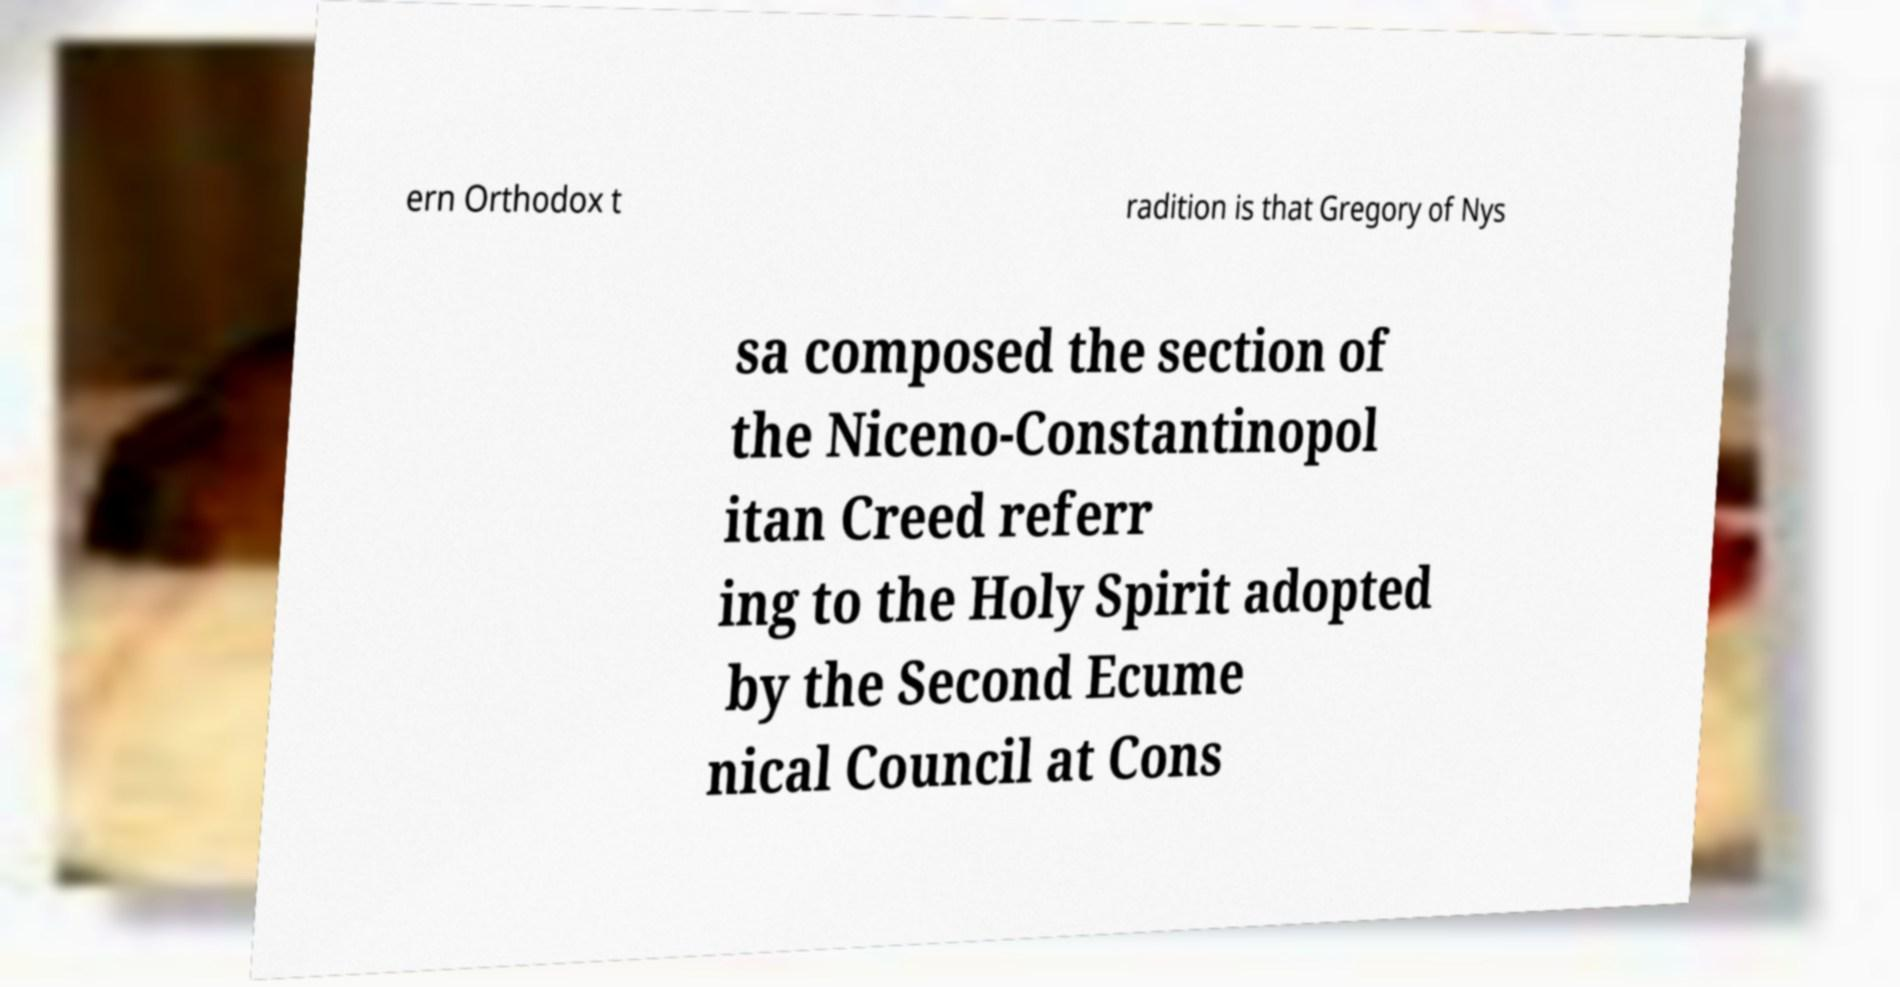Can you accurately transcribe the text from the provided image for me? ern Orthodox t radition is that Gregory of Nys sa composed the section of the Niceno-Constantinopol itan Creed referr ing to the Holy Spirit adopted by the Second Ecume nical Council at Cons 